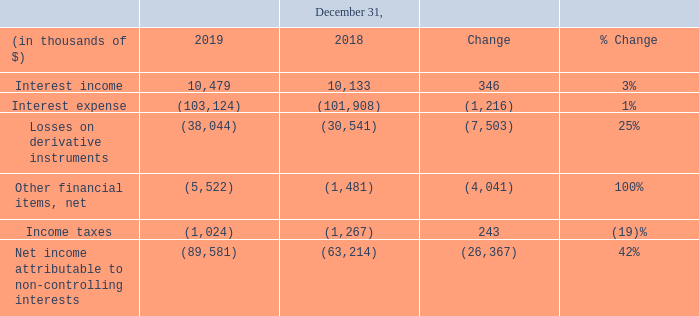Other non-operating results
The following details our other consolidated results for the years ended December 31, 2019 and 2018:
Interest expense: Interest expense increased by $1.2 million to $103.1 million for the year ended December 31, 2019 compared to $101.9 million for the same period in 2018. The increase in interest expense was primarily due to:
• $28.9 million lower capitalized interest on borrowing costs in relation to our investment in the Hilli FLNG conversion following acceptance of the vessel by the charterer in May 2018; and
• $1.5 million interest on the term loan facility, drawn in September 2019.
This was partially offset by reduced interest costs due to lower LIBOR rates, resulting in:
• $12.4 million decrease in interest expense arising on the loan facilities of our consolidated lessor VIEs;
• $8.7 million capitalized interest on borrowing costs in relation to our investments;
• $6.5 million decrease in interest expense incurred on the deposits received from Golar Partners following application of the deposit to the Hilli acquisition price and the conversion of the Hilli shareholder loans to equity following the Hilli Disposal in July 2018; and
• $1.0 million decrease in interest expense on the Hilli letter of credit, due to a contractual step down in the Hilli letter of credit from $300 million to $250 million in May 2019, and a further step down to $125 million in November 2019.
Losses on derivative instruments: Losses on derivative instruments increased by $7.5 million to a loss of $38.0 million for the year ended December 31, 2019 compared to a loss of $30.5 million for the same period in 2018. The movement was primarily due to:
Net unrealized and realized (losses)/gains on interest rate swap agreements: As of December 31, 2019, we have an interest rate swap portfolio with a notional amount of $737.5 million, none of which are designated as hedges for accounting purposes. Net unrealized losses on the interest rate swaps increased to a loss of $16.5 million for the year ended December 31, 2019 compared to a gain of $0.6 million for the same period in 2018, due to a decline in the long-term swap rates, partially offset by the decreased notional value of our swap portfolio over the period. Realized gains on our interest rate swaps decreased to a gain of $6.4 million for the year ended December 31, 2019, compared to a gain of $8.1 million for the same period in 2018. The decrease was primarily due to lower LIBOR rates for the year ended December 31, 2019.
Unrealized losses on Total Return Swap: In December 2014, we established a three month facility for a Stock Indexed Total Return Swap Programme or Equity Swap Line with DNB Bank ASA in connection with a share buyback scheme. In November 2019, we repurchased 1.5 million shares underlying the equity swap. The remaining facility has been extended to March 2020. The equity swap derivatives mark-to-market adjustment resulted in a net loss of $30.5 million recognized in the year ended December 31, 2019 compared to a loss of $30.7 million for the same period in 2018. The losses in 2019 and 2018 are due to the decline in our share price.
Unrealized mark-to-market losses on Earn-Out Units: This relates to the mark-to-market movement on the Earn-Out Units issuable in connection with the IDR reset transaction in October 2016, which we recognize as a derivative asset in our consolidated financial statements. The decrease in Golar Partners' quarterly distribution to $0.4042 per common unit on October 24, 2018 resulted in the contingent Earn-Out Units arising out of the IDR reset transaction in October 2016 not crystallizing and, accordingly, we recognized a mark-to-market loss of $7.4 million for the year ended December 31, 2018, effectively reducing the derivative asset to $nil at December 31, 2018. There was no comparative movement for the year ended December 31, 2019.
Other financial items, net: Other financial items, net decreased by $4.0 million to a loss of $5.5 million for the year ended December 31, 2019 compared to $1.5 million for the same period in 2018 primarily as a result of consolidating our lessor VIEs.
Net income attributable to non-controlling interests: Net income attributable to non-controlling interests increased by $26.4 million to $89.6 million for the year ended December 31, 2019 compared to $63.2 million for the same period in 2018 mainly due to the completion of the Hilli Disposal in July 2018. The non-controlling interest in relation to the Hilli Disposal for the year ended December 31, 2019 amounted to $61.7 million, compared to $31.3 million for the same period in 2018.
The net income attributable to non-controlling interests comprises of: • $36.5 million and $19.7 million in relation to the non-controlling shareholders who hold interests in Hilli LLC for the year ended December 31, 2019 and 2018, respectively; • $0.5 million in relation to the non-controlling shareholders who hold interests in Gimi MS Corporation for the year ended December 31, 2019, following the subscription of 30% equity interest by First FLNG Holdings in April 2019; and • $28.3 million and $31.9 million in relation to the equity interests in our remaining lessor VIEs for the year ended December 31, 2019 and 2018, respectively.
In which years was the other consolidated results recorded for? 2018, 2019. What was the reason for the change in other financial items, net? Primarily as a result of consolidating our lessor vies. What accounted for the increase in net income attributable to non-controlling interests? Due to the completion of the hilli disposal in july 2018. Which year has a higher income tax? (1,267) > (1,024)
Answer: 2018. What was the change in net unrealized losses on the interest rate swaps?
Answer scale should be: million. -16.5 - 0.6 
Answer: -17.1. What was the percentage change in net income attributable in relation to the non-controlling shareholders who hold interests in Hilli LLC?
Answer scale should be: percent. (36.5 - 19.7)/19.7 
Answer: 85.28. 